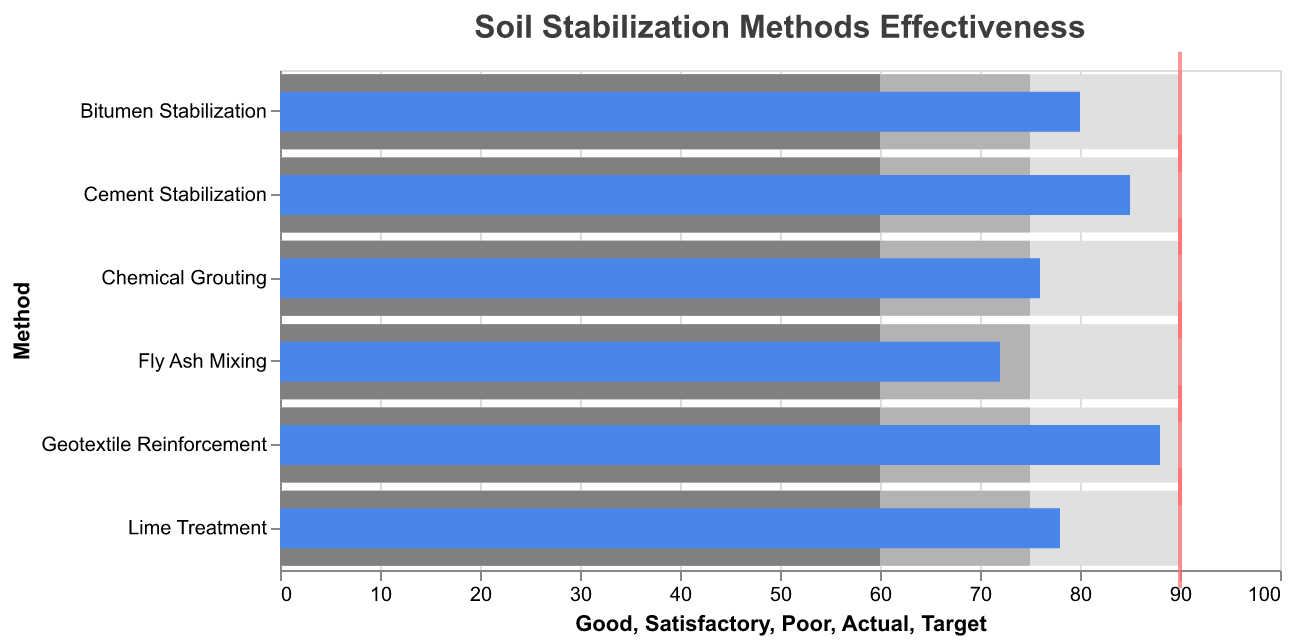What is the highest actual effectiveness score among all methods? To find the highest actual effectiveness score, look at the "Actual" column for all methods. The highest value is 88 for Geotextile Reinforcement.
Answer: 88 How does Cement Stabilization compare to the target benchmark? Cement Stabilization has an actual value of 85. The target benchmark is 90, so it falls short by 5 points.
Answer: -5 Which method has the lowest actual effectiveness against the target? Reviewing the "Actual" column, Fly Ash Mixing has the lowest effectiveness score of 72 against a target of 90.
Answer: Fly Ash Mixing What is the difference in actual effectiveness between Lime Treatment and Bitumen Stabilization? Lime Treatment has an actual value of 78, and Bitumen Stabilization has 80. The difference is 80 - 78, which is 2.
Answer: 2 Which methods meet or exceed the "Satisfactory" level but do not reach the "Good" level? Look at the "Actual" values compared to the "Satisfactory" (75) and "Good" (90) levels. Lime Treatment (78), Fly Ash Mixing (72), Bitumen Stabilization (80), and Chemical Grouting (76) fall in this range.
Answer: Lime Treatment, Fly Ash Mixing, Bitumen Stabilization, Chemical Grouting What is the average actual effectiveness score across all methods? Sum up all actual values (85 + 78 + 72 + 80 + 88 + 76) which equals 479. Divide by the number of methods (6). 479 ÷ 6 = 79.83.
Answer: 79.83 Which method comes closest to meeting the target benchmark but does not exceed it? Find the actual values closest to the target of 90 without exceeding it. Geotextile Reinforcement at 88 is the closest without exceeding.
Answer: Geotextile Reinforcement Among the methods, which has an actual effectiveness furthest below the satisfactory level? Satisfactory level is 75. Compare actual values below this level. Fly Ash Mixing with a score of 72 is the furthest below, falling 3 points short.
Answer: Fly Ash Mixing What is the total sum of the differences between actual scores and the target benchmark for all methods? Calculate the absolute differences for each method from the target (90): (90-85) + (90-78) + (90-72) + (90-80) + (90-88) + (90-76) = 5 + 12 + 18 + 10 + 2 + 14 = 61
Answer: 61 Which methods achieve more than 80% of the target benchmark? 80% of the target benchmark (90) is 72. Looking at actual values, methods exceeding 72 are Cement Stabilization (85), Lime Treatment (78), Bitumen Stabilization (80), Geotextile Reinforcement (88), and Chemical Grouting (76).
Answer: Cement Stabilization, Lime Treatment, Bitumen Stabilization, Geotextile Reinforcement, Chemical Grouting 